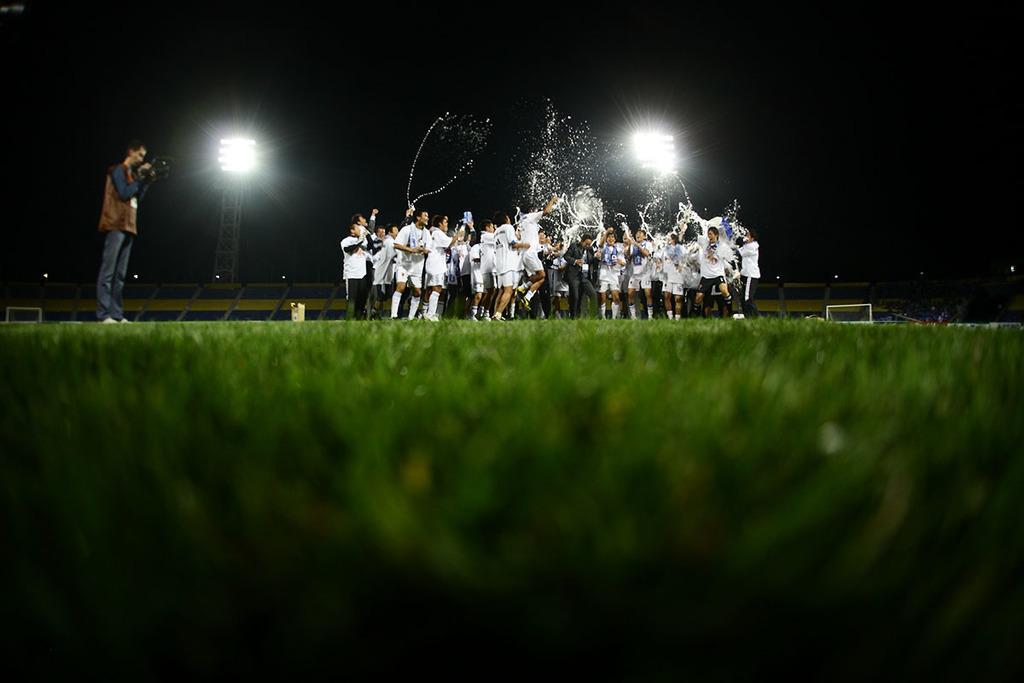Please provide a concise description of this image. This image consists of many people wearing jerseys. At the bottom, there is green grass on the ground. It looks like a stadium. On the left, there is a man wearing a brown jacket is holding a camera. In the background, there are lights. At the top, there is sky. And we can see a person jumping in the front. 